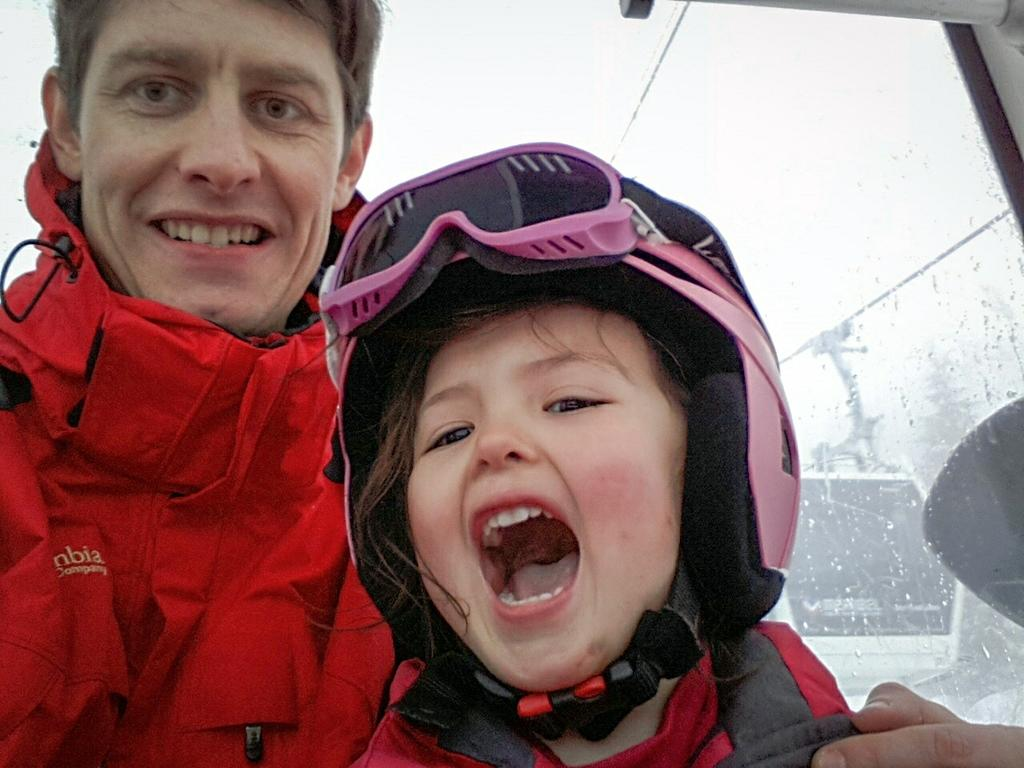Who is present in the image? There is a man and a kid in the image. What are the expressions on their faces? Both the man and the kid are smiling in the image. What type of clothing are they wearing? The man and the kid are wearing jackets in the image. What type of linen is visible in the image? There is no linen present in the image. Can you tell me how many pickles are on the table in the image? There is no table or pickles present in the image. 